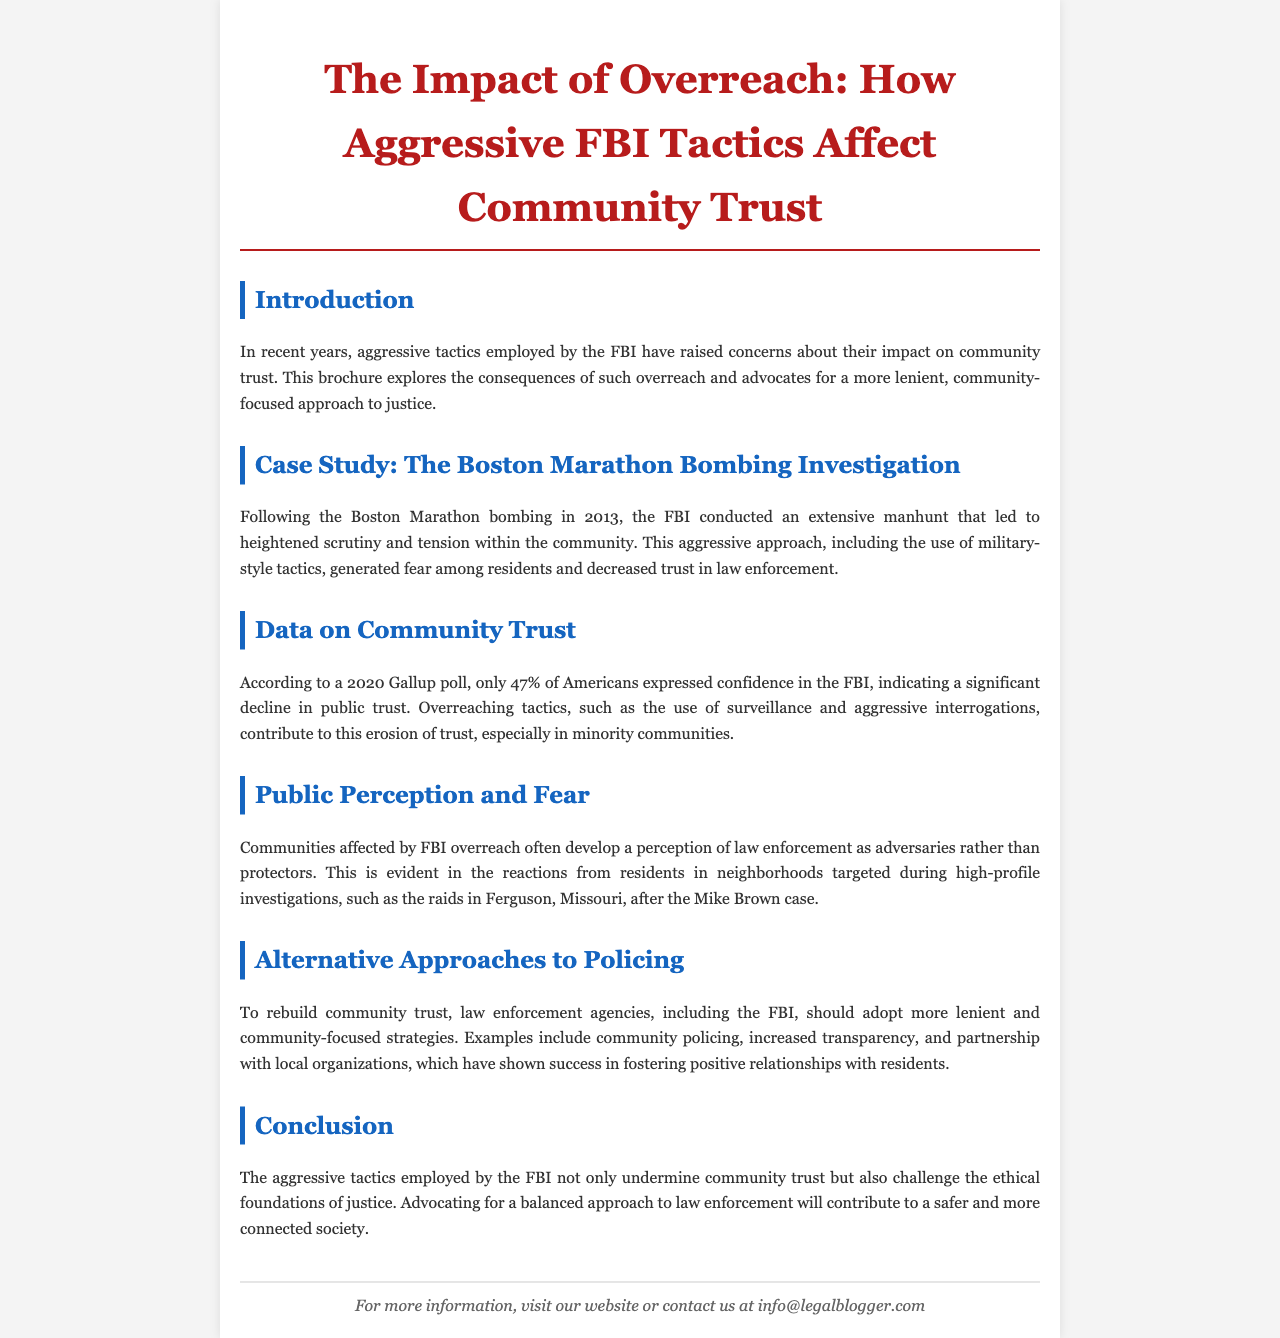What year did the Boston Marathon bombing occur? The document states that the bombing occurred in 2013.
Answer: 2013 What percentage of Americans expressed confidence in the FBI in 2020? The document cites a Gallup poll showing that 47% of Americans expressed confidence in the FBI.
Answer: 47% Which case study is mentioned in the document? The case study highlighted in the brochure is the Boston Marathon bombing investigation.
Answer: Boston Marathon bombing investigation What is one suggested alternative to aggressive FBI tactics? The document suggests community policing as an alternative approach to law enforcement.
Answer: Community policing What is the primary focus of the brochure? The brochure primarily focuses on the impact of aggressive FBI tactics on community trust.
Answer: Impact of aggressive FBI tactics on community trust How did residents in affected neighborhoods perceive law enforcement due to FBI overreach? The document mentions that residents developed a perception of law enforcement as adversaries rather than protectors.
Answer: Adversaries rather than protectors What should law enforcement agencies adopt to rebuild community trust? The document advocates for a more lenient and community-focused approach.
Answer: More lenient and community-focused approach What style of tactics is criticized in the document? The document criticizes military-style tactics used by the FBI.
Answer: Military-style tactics 